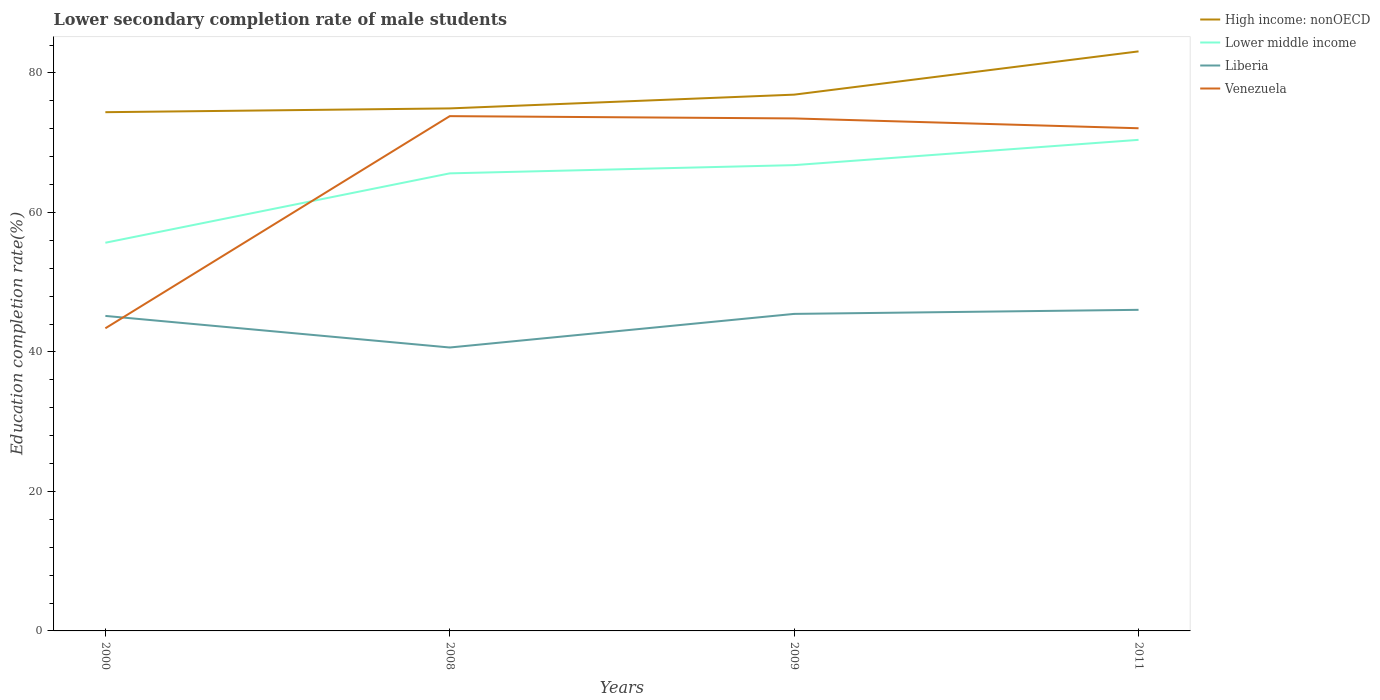Does the line corresponding to High income: nonOECD intersect with the line corresponding to Venezuela?
Your response must be concise. No. Across all years, what is the maximum lower secondary completion rate of male students in Lower middle income?
Offer a terse response. 55.66. In which year was the lower secondary completion rate of male students in Liberia maximum?
Ensure brevity in your answer.  2008. What is the total lower secondary completion rate of male students in Liberia in the graph?
Your answer should be very brief. -0.29. What is the difference between the highest and the second highest lower secondary completion rate of male students in High income: nonOECD?
Offer a very short reply. 8.72. Does the graph contain any zero values?
Make the answer very short. No. Does the graph contain grids?
Give a very brief answer. No. Where does the legend appear in the graph?
Your answer should be very brief. Top right. How are the legend labels stacked?
Make the answer very short. Vertical. What is the title of the graph?
Your response must be concise. Lower secondary completion rate of male students. What is the label or title of the X-axis?
Your response must be concise. Years. What is the label or title of the Y-axis?
Keep it short and to the point. Education completion rate(%). What is the Education completion rate(%) in High income: nonOECD in 2000?
Offer a very short reply. 74.37. What is the Education completion rate(%) of Lower middle income in 2000?
Provide a short and direct response. 55.66. What is the Education completion rate(%) of Liberia in 2000?
Give a very brief answer. 45.16. What is the Education completion rate(%) in Venezuela in 2000?
Offer a very short reply. 43.39. What is the Education completion rate(%) in High income: nonOECD in 2008?
Your answer should be compact. 74.92. What is the Education completion rate(%) of Lower middle income in 2008?
Keep it short and to the point. 65.6. What is the Education completion rate(%) of Liberia in 2008?
Offer a very short reply. 40.64. What is the Education completion rate(%) in Venezuela in 2008?
Provide a succinct answer. 73.81. What is the Education completion rate(%) in High income: nonOECD in 2009?
Your answer should be compact. 76.89. What is the Education completion rate(%) of Lower middle income in 2009?
Your answer should be very brief. 66.78. What is the Education completion rate(%) of Liberia in 2009?
Your response must be concise. 45.45. What is the Education completion rate(%) of Venezuela in 2009?
Offer a terse response. 73.48. What is the Education completion rate(%) of High income: nonOECD in 2011?
Give a very brief answer. 83.09. What is the Education completion rate(%) of Lower middle income in 2011?
Make the answer very short. 70.41. What is the Education completion rate(%) of Liberia in 2011?
Provide a succinct answer. 46.04. What is the Education completion rate(%) of Venezuela in 2011?
Your response must be concise. 72.07. Across all years, what is the maximum Education completion rate(%) of High income: nonOECD?
Your answer should be very brief. 83.09. Across all years, what is the maximum Education completion rate(%) in Lower middle income?
Keep it short and to the point. 70.41. Across all years, what is the maximum Education completion rate(%) in Liberia?
Your answer should be very brief. 46.04. Across all years, what is the maximum Education completion rate(%) of Venezuela?
Provide a short and direct response. 73.81. Across all years, what is the minimum Education completion rate(%) in High income: nonOECD?
Your answer should be compact. 74.37. Across all years, what is the minimum Education completion rate(%) in Lower middle income?
Offer a terse response. 55.66. Across all years, what is the minimum Education completion rate(%) in Liberia?
Offer a terse response. 40.64. Across all years, what is the minimum Education completion rate(%) of Venezuela?
Your response must be concise. 43.39. What is the total Education completion rate(%) of High income: nonOECD in the graph?
Your response must be concise. 309.27. What is the total Education completion rate(%) in Lower middle income in the graph?
Provide a succinct answer. 258.45. What is the total Education completion rate(%) of Liberia in the graph?
Ensure brevity in your answer.  177.29. What is the total Education completion rate(%) of Venezuela in the graph?
Provide a short and direct response. 262.75. What is the difference between the Education completion rate(%) in High income: nonOECD in 2000 and that in 2008?
Give a very brief answer. -0.54. What is the difference between the Education completion rate(%) of Lower middle income in 2000 and that in 2008?
Your answer should be compact. -9.95. What is the difference between the Education completion rate(%) of Liberia in 2000 and that in 2008?
Provide a succinct answer. 4.53. What is the difference between the Education completion rate(%) of Venezuela in 2000 and that in 2008?
Your answer should be compact. -30.42. What is the difference between the Education completion rate(%) in High income: nonOECD in 2000 and that in 2009?
Offer a very short reply. -2.51. What is the difference between the Education completion rate(%) in Lower middle income in 2000 and that in 2009?
Ensure brevity in your answer.  -11.13. What is the difference between the Education completion rate(%) in Liberia in 2000 and that in 2009?
Give a very brief answer. -0.29. What is the difference between the Education completion rate(%) in Venezuela in 2000 and that in 2009?
Your answer should be compact. -30.09. What is the difference between the Education completion rate(%) of High income: nonOECD in 2000 and that in 2011?
Provide a short and direct response. -8.72. What is the difference between the Education completion rate(%) of Lower middle income in 2000 and that in 2011?
Offer a terse response. -14.75. What is the difference between the Education completion rate(%) of Liberia in 2000 and that in 2011?
Make the answer very short. -0.87. What is the difference between the Education completion rate(%) of Venezuela in 2000 and that in 2011?
Offer a terse response. -28.68. What is the difference between the Education completion rate(%) in High income: nonOECD in 2008 and that in 2009?
Keep it short and to the point. -1.97. What is the difference between the Education completion rate(%) in Lower middle income in 2008 and that in 2009?
Offer a very short reply. -1.18. What is the difference between the Education completion rate(%) of Liberia in 2008 and that in 2009?
Keep it short and to the point. -4.82. What is the difference between the Education completion rate(%) in Venezuela in 2008 and that in 2009?
Your answer should be very brief. 0.33. What is the difference between the Education completion rate(%) of High income: nonOECD in 2008 and that in 2011?
Your response must be concise. -8.18. What is the difference between the Education completion rate(%) in Lower middle income in 2008 and that in 2011?
Make the answer very short. -4.8. What is the difference between the Education completion rate(%) in Liberia in 2008 and that in 2011?
Make the answer very short. -5.4. What is the difference between the Education completion rate(%) of Venezuela in 2008 and that in 2011?
Make the answer very short. 1.74. What is the difference between the Education completion rate(%) in High income: nonOECD in 2009 and that in 2011?
Offer a terse response. -6.2. What is the difference between the Education completion rate(%) in Lower middle income in 2009 and that in 2011?
Make the answer very short. -3.62. What is the difference between the Education completion rate(%) of Liberia in 2009 and that in 2011?
Your answer should be compact. -0.58. What is the difference between the Education completion rate(%) in Venezuela in 2009 and that in 2011?
Provide a short and direct response. 1.41. What is the difference between the Education completion rate(%) in High income: nonOECD in 2000 and the Education completion rate(%) in Lower middle income in 2008?
Keep it short and to the point. 8.77. What is the difference between the Education completion rate(%) of High income: nonOECD in 2000 and the Education completion rate(%) of Liberia in 2008?
Your answer should be compact. 33.74. What is the difference between the Education completion rate(%) in High income: nonOECD in 2000 and the Education completion rate(%) in Venezuela in 2008?
Offer a very short reply. 0.57. What is the difference between the Education completion rate(%) in Lower middle income in 2000 and the Education completion rate(%) in Liberia in 2008?
Your response must be concise. 15.02. What is the difference between the Education completion rate(%) of Lower middle income in 2000 and the Education completion rate(%) of Venezuela in 2008?
Keep it short and to the point. -18.15. What is the difference between the Education completion rate(%) of Liberia in 2000 and the Education completion rate(%) of Venezuela in 2008?
Provide a succinct answer. -28.64. What is the difference between the Education completion rate(%) of High income: nonOECD in 2000 and the Education completion rate(%) of Lower middle income in 2009?
Your answer should be very brief. 7.59. What is the difference between the Education completion rate(%) of High income: nonOECD in 2000 and the Education completion rate(%) of Liberia in 2009?
Your response must be concise. 28.92. What is the difference between the Education completion rate(%) in High income: nonOECD in 2000 and the Education completion rate(%) in Venezuela in 2009?
Ensure brevity in your answer.  0.9. What is the difference between the Education completion rate(%) of Lower middle income in 2000 and the Education completion rate(%) of Liberia in 2009?
Make the answer very short. 10.2. What is the difference between the Education completion rate(%) of Lower middle income in 2000 and the Education completion rate(%) of Venezuela in 2009?
Your answer should be compact. -17.82. What is the difference between the Education completion rate(%) of Liberia in 2000 and the Education completion rate(%) of Venezuela in 2009?
Provide a succinct answer. -28.31. What is the difference between the Education completion rate(%) in High income: nonOECD in 2000 and the Education completion rate(%) in Lower middle income in 2011?
Give a very brief answer. 3.97. What is the difference between the Education completion rate(%) in High income: nonOECD in 2000 and the Education completion rate(%) in Liberia in 2011?
Your answer should be very brief. 28.34. What is the difference between the Education completion rate(%) of High income: nonOECD in 2000 and the Education completion rate(%) of Venezuela in 2011?
Provide a succinct answer. 2.3. What is the difference between the Education completion rate(%) of Lower middle income in 2000 and the Education completion rate(%) of Liberia in 2011?
Your answer should be compact. 9.62. What is the difference between the Education completion rate(%) of Lower middle income in 2000 and the Education completion rate(%) of Venezuela in 2011?
Make the answer very short. -16.41. What is the difference between the Education completion rate(%) in Liberia in 2000 and the Education completion rate(%) in Venezuela in 2011?
Offer a terse response. -26.91. What is the difference between the Education completion rate(%) of High income: nonOECD in 2008 and the Education completion rate(%) of Lower middle income in 2009?
Keep it short and to the point. 8.13. What is the difference between the Education completion rate(%) in High income: nonOECD in 2008 and the Education completion rate(%) in Liberia in 2009?
Provide a succinct answer. 29.46. What is the difference between the Education completion rate(%) of High income: nonOECD in 2008 and the Education completion rate(%) of Venezuela in 2009?
Your answer should be very brief. 1.44. What is the difference between the Education completion rate(%) in Lower middle income in 2008 and the Education completion rate(%) in Liberia in 2009?
Give a very brief answer. 20.15. What is the difference between the Education completion rate(%) in Lower middle income in 2008 and the Education completion rate(%) in Venezuela in 2009?
Offer a terse response. -7.87. What is the difference between the Education completion rate(%) of Liberia in 2008 and the Education completion rate(%) of Venezuela in 2009?
Offer a very short reply. -32.84. What is the difference between the Education completion rate(%) of High income: nonOECD in 2008 and the Education completion rate(%) of Lower middle income in 2011?
Make the answer very short. 4.51. What is the difference between the Education completion rate(%) of High income: nonOECD in 2008 and the Education completion rate(%) of Liberia in 2011?
Ensure brevity in your answer.  28.88. What is the difference between the Education completion rate(%) in High income: nonOECD in 2008 and the Education completion rate(%) in Venezuela in 2011?
Provide a short and direct response. 2.85. What is the difference between the Education completion rate(%) in Lower middle income in 2008 and the Education completion rate(%) in Liberia in 2011?
Give a very brief answer. 19.57. What is the difference between the Education completion rate(%) of Lower middle income in 2008 and the Education completion rate(%) of Venezuela in 2011?
Your response must be concise. -6.47. What is the difference between the Education completion rate(%) in Liberia in 2008 and the Education completion rate(%) in Venezuela in 2011?
Make the answer very short. -31.43. What is the difference between the Education completion rate(%) in High income: nonOECD in 2009 and the Education completion rate(%) in Lower middle income in 2011?
Provide a succinct answer. 6.48. What is the difference between the Education completion rate(%) in High income: nonOECD in 2009 and the Education completion rate(%) in Liberia in 2011?
Offer a terse response. 30.85. What is the difference between the Education completion rate(%) of High income: nonOECD in 2009 and the Education completion rate(%) of Venezuela in 2011?
Provide a short and direct response. 4.82. What is the difference between the Education completion rate(%) in Lower middle income in 2009 and the Education completion rate(%) in Liberia in 2011?
Your response must be concise. 20.75. What is the difference between the Education completion rate(%) of Lower middle income in 2009 and the Education completion rate(%) of Venezuela in 2011?
Give a very brief answer. -5.29. What is the difference between the Education completion rate(%) of Liberia in 2009 and the Education completion rate(%) of Venezuela in 2011?
Offer a terse response. -26.62. What is the average Education completion rate(%) in High income: nonOECD per year?
Your response must be concise. 77.32. What is the average Education completion rate(%) of Lower middle income per year?
Your answer should be very brief. 64.61. What is the average Education completion rate(%) in Liberia per year?
Make the answer very short. 44.32. What is the average Education completion rate(%) of Venezuela per year?
Your answer should be very brief. 65.69. In the year 2000, what is the difference between the Education completion rate(%) of High income: nonOECD and Education completion rate(%) of Lower middle income?
Your response must be concise. 18.72. In the year 2000, what is the difference between the Education completion rate(%) of High income: nonOECD and Education completion rate(%) of Liberia?
Offer a terse response. 29.21. In the year 2000, what is the difference between the Education completion rate(%) in High income: nonOECD and Education completion rate(%) in Venezuela?
Your response must be concise. 30.98. In the year 2000, what is the difference between the Education completion rate(%) in Lower middle income and Education completion rate(%) in Liberia?
Give a very brief answer. 10.49. In the year 2000, what is the difference between the Education completion rate(%) in Lower middle income and Education completion rate(%) in Venezuela?
Keep it short and to the point. 12.27. In the year 2000, what is the difference between the Education completion rate(%) in Liberia and Education completion rate(%) in Venezuela?
Ensure brevity in your answer.  1.77. In the year 2008, what is the difference between the Education completion rate(%) of High income: nonOECD and Education completion rate(%) of Lower middle income?
Offer a terse response. 9.31. In the year 2008, what is the difference between the Education completion rate(%) in High income: nonOECD and Education completion rate(%) in Liberia?
Ensure brevity in your answer.  34.28. In the year 2008, what is the difference between the Education completion rate(%) in High income: nonOECD and Education completion rate(%) in Venezuela?
Provide a short and direct response. 1.11. In the year 2008, what is the difference between the Education completion rate(%) in Lower middle income and Education completion rate(%) in Liberia?
Offer a terse response. 24.97. In the year 2008, what is the difference between the Education completion rate(%) of Lower middle income and Education completion rate(%) of Venezuela?
Provide a short and direct response. -8.2. In the year 2008, what is the difference between the Education completion rate(%) of Liberia and Education completion rate(%) of Venezuela?
Provide a short and direct response. -33.17. In the year 2009, what is the difference between the Education completion rate(%) in High income: nonOECD and Education completion rate(%) in Lower middle income?
Make the answer very short. 10.11. In the year 2009, what is the difference between the Education completion rate(%) of High income: nonOECD and Education completion rate(%) of Liberia?
Provide a succinct answer. 31.43. In the year 2009, what is the difference between the Education completion rate(%) of High income: nonOECD and Education completion rate(%) of Venezuela?
Your answer should be compact. 3.41. In the year 2009, what is the difference between the Education completion rate(%) in Lower middle income and Education completion rate(%) in Liberia?
Ensure brevity in your answer.  21.33. In the year 2009, what is the difference between the Education completion rate(%) in Lower middle income and Education completion rate(%) in Venezuela?
Your answer should be compact. -6.69. In the year 2009, what is the difference between the Education completion rate(%) of Liberia and Education completion rate(%) of Venezuela?
Offer a very short reply. -28.02. In the year 2011, what is the difference between the Education completion rate(%) of High income: nonOECD and Education completion rate(%) of Lower middle income?
Keep it short and to the point. 12.68. In the year 2011, what is the difference between the Education completion rate(%) of High income: nonOECD and Education completion rate(%) of Liberia?
Offer a very short reply. 37.06. In the year 2011, what is the difference between the Education completion rate(%) of High income: nonOECD and Education completion rate(%) of Venezuela?
Your answer should be very brief. 11.02. In the year 2011, what is the difference between the Education completion rate(%) of Lower middle income and Education completion rate(%) of Liberia?
Offer a very short reply. 24.37. In the year 2011, what is the difference between the Education completion rate(%) in Lower middle income and Education completion rate(%) in Venezuela?
Your answer should be very brief. -1.66. In the year 2011, what is the difference between the Education completion rate(%) of Liberia and Education completion rate(%) of Venezuela?
Your answer should be very brief. -26.03. What is the ratio of the Education completion rate(%) of Lower middle income in 2000 to that in 2008?
Ensure brevity in your answer.  0.85. What is the ratio of the Education completion rate(%) of Liberia in 2000 to that in 2008?
Your answer should be very brief. 1.11. What is the ratio of the Education completion rate(%) of Venezuela in 2000 to that in 2008?
Offer a very short reply. 0.59. What is the ratio of the Education completion rate(%) in High income: nonOECD in 2000 to that in 2009?
Your response must be concise. 0.97. What is the ratio of the Education completion rate(%) of Lower middle income in 2000 to that in 2009?
Make the answer very short. 0.83. What is the ratio of the Education completion rate(%) in Liberia in 2000 to that in 2009?
Your answer should be compact. 0.99. What is the ratio of the Education completion rate(%) of Venezuela in 2000 to that in 2009?
Provide a succinct answer. 0.59. What is the ratio of the Education completion rate(%) in High income: nonOECD in 2000 to that in 2011?
Your answer should be very brief. 0.9. What is the ratio of the Education completion rate(%) in Lower middle income in 2000 to that in 2011?
Your answer should be very brief. 0.79. What is the ratio of the Education completion rate(%) of Liberia in 2000 to that in 2011?
Keep it short and to the point. 0.98. What is the ratio of the Education completion rate(%) in Venezuela in 2000 to that in 2011?
Make the answer very short. 0.6. What is the ratio of the Education completion rate(%) of High income: nonOECD in 2008 to that in 2009?
Keep it short and to the point. 0.97. What is the ratio of the Education completion rate(%) of Lower middle income in 2008 to that in 2009?
Keep it short and to the point. 0.98. What is the ratio of the Education completion rate(%) in Liberia in 2008 to that in 2009?
Provide a succinct answer. 0.89. What is the ratio of the Education completion rate(%) in High income: nonOECD in 2008 to that in 2011?
Your response must be concise. 0.9. What is the ratio of the Education completion rate(%) of Lower middle income in 2008 to that in 2011?
Keep it short and to the point. 0.93. What is the ratio of the Education completion rate(%) in Liberia in 2008 to that in 2011?
Provide a succinct answer. 0.88. What is the ratio of the Education completion rate(%) in Venezuela in 2008 to that in 2011?
Keep it short and to the point. 1.02. What is the ratio of the Education completion rate(%) of High income: nonOECD in 2009 to that in 2011?
Offer a very short reply. 0.93. What is the ratio of the Education completion rate(%) in Lower middle income in 2009 to that in 2011?
Provide a succinct answer. 0.95. What is the ratio of the Education completion rate(%) of Liberia in 2009 to that in 2011?
Your answer should be very brief. 0.99. What is the ratio of the Education completion rate(%) in Venezuela in 2009 to that in 2011?
Provide a short and direct response. 1.02. What is the difference between the highest and the second highest Education completion rate(%) of High income: nonOECD?
Give a very brief answer. 6.2. What is the difference between the highest and the second highest Education completion rate(%) of Lower middle income?
Keep it short and to the point. 3.62. What is the difference between the highest and the second highest Education completion rate(%) in Liberia?
Offer a very short reply. 0.58. What is the difference between the highest and the second highest Education completion rate(%) in Venezuela?
Offer a very short reply. 0.33. What is the difference between the highest and the lowest Education completion rate(%) in High income: nonOECD?
Your answer should be very brief. 8.72. What is the difference between the highest and the lowest Education completion rate(%) in Lower middle income?
Your response must be concise. 14.75. What is the difference between the highest and the lowest Education completion rate(%) in Liberia?
Provide a short and direct response. 5.4. What is the difference between the highest and the lowest Education completion rate(%) in Venezuela?
Ensure brevity in your answer.  30.42. 